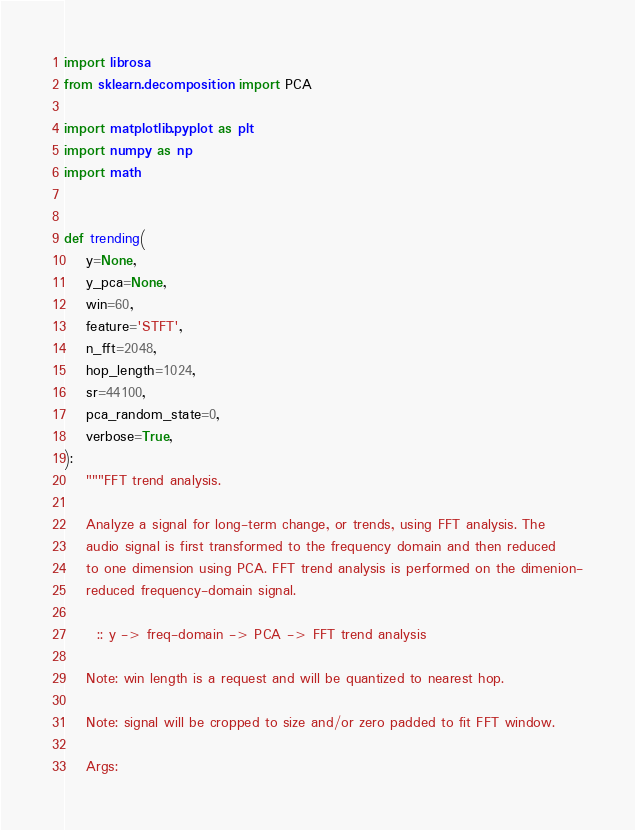Convert code to text. <code><loc_0><loc_0><loc_500><loc_500><_Python_>import librosa
from sklearn.decomposition import PCA

import matplotlib.pyplot as plt
import numpy as np
import math


def trending(
    y=None,
    y_pca=None,
    win=60,
    feature='STFT',
    n_fft=2048,
    hop_length=1024,
    sr=44100,
    pca_random_state=0,
    verbose=True,
):
    """FFT trend analysis.

    Analyze a signal for long-term change, or trends, using FFT analysis. The
    audio signal is first transformed to the frequency domain and then reduced
    to one dimension using PCA. FFT trend analysis is performed on the dimenion-
    reduced frequency-domain signal.

      :: y -> freq-domain -> PCA -> FFT trend analysis

    Note: win length is a request and will be quantized to nearest hop.

    Note: signal will be cropped to size and/or zero padded to fit FFT window.

    Args:</code> 